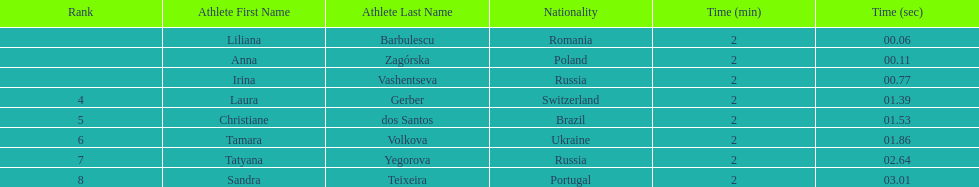What are the names of the competitors? Liliana Barbulescu, Anna Zagórska, Irina Vashentseva, Laura Gerber, Christiane dos Santos, Tamara Volkova, Tatyana Yegorova, Sandra Teixeira. Which finalist finished the fastest? Liliana Barbulescu. 